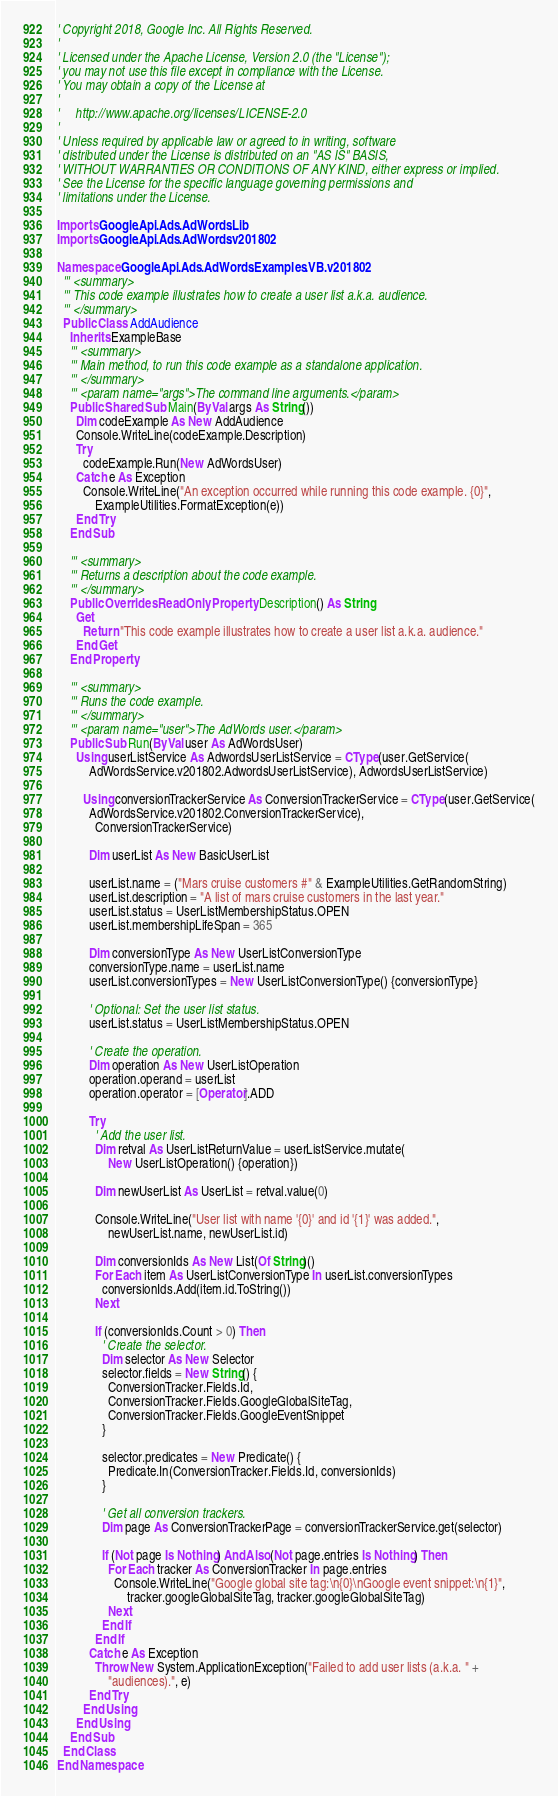Convert code to text. <code><loc_0><loc_0><loc_500><loc_500><_VisualBasic_>' Copyright 2018, Google Inc. All Rights Reserved.
'
' Licensed under the Apache License, Version 2.0 (the "License");
' you may not use this file except in compliance with the License.
' You may obtain a copy of the License at
'
'     http://www.apache.org/licenses/LICENSE-2.0
'
' Unless required by applicable law or agreed to in writing, software
' distributed under the License is distributed on an "AS IS" BASIS,
' WITHOUT WARRANTIES OR CONDITIONS OF ANY KIND, either express or implied.
' See the License for the specific language governing permissions and
' limitations under the License.

Imports Google.Api.Ads.AdWords.Lib
Imports Google.Api.Ads.AdWords.v201802

Namespace Google.Api.Ads.AdWords.Examples.VB.v201802
  ''' <summary>
  ''' This code example illustrates how to create a user list a.k.a. audience.
  ''' </summary>
  Public Class AddAudience
    Inherits ExampleBase
    ''' <summary>
    ''' Main method, to run this code example as a standalone application.
    ''' </summary>
    ''' <param name="args">The command line arguments.</param>
    Public Shared Sub Main(ByVal args As String())
      Dim codeExample As New AddAudience
      Console.WriteLine(codeExample.Description)
      Try
        codeExample.Run(New AdWordsUser)
      Catch e As Exception
        Console.WriteLine("An exception occurred while running this code example. {0}",
            ExampleUtilities.FormatException(e))
      End Try
    End Sub

    ''' <summary>
    ''' Returns a description about the code example.
    ''' </summary>
    Public Overrides ReadOnly Property Description() As String
      Get
        Return "This code example illustrates how to create a user list a.k.a. audience."
      End Get
    End Property

    ''' <summary>
    ''' Runs the code example.
    ''' </summary>
    ''' <param name="user">The AdWords user.</param>
    Public Sub Run(ByVal user As AdWordsUser)
      Using userListService As AdwordsUserListService = CType(user.GetService(
          AdWordsService.v201802.AdwordsUserListService), AdwordsUserListService)

        Using conversionTrackerService As ConversionTrackerService = CType(user.GetService(
          AdWordsService.v201802.ConversionTrackerService),
            ConversionTrackerService)

          Dim userList As New BasicUserList

          userList.name = ("Mars cruise customers #" & ExampleUtilities.GetRandomString)
          userList.description = "A list of mars cruise customers in the last year."
          userList.status = UserListMembershipStatus.OPEN
          userList.membershipLifeSpan = 365

          Dim conversionType As New UserListConversionType
          conversionType.name = userList.name
          userList.conversionTypes = New UserListConversionType() {conversionType}

          ' Optional: Set the user list status.
          userList.status = UserListMembershipStatus.OPEN

          ' Create the operation.
          Dim operation As New UserListOperation
          operation.operand = userList
          operation.operator = [Operator].ADD

          Try
            ' Add the user list.
            Dim retval As UserListReturnValue = userListService.mutate(
                New UserListOperation() {operation})

            Dim newUserList As UserList = retval.value(0)

            Console.WriteLine("User list with name '{0}' and id '{1}' was added.",
                newUserList.name, newUserList.id)

            Dim conversionIds As New List(Of String)()
            For Each item As UserListConversionType In userList.conversionTypes
              conversionIds.Add(item.id.ToString())
            Next

            If (conversionIds.Count > 0) Then
              ' Create the selector.
              Dim selector As New Selector
              selector.fields = New String() {
                ConversionTracker.Fields.Id,
                ConversionTracker.Fields.GoogleGlobalSiteTag,
                ConversionTracker.Fields.GoogleEventSnippet
              }

              selector.predicates = New Predicate() {
                Predicate.In(ConversionTracker.Fields.Id, conversionIds)
              }

              ' Get all conversion trackers.
              Dim page As ConversionTrackerPage = conversionTrackerService.get(selector)

              If (Not page Is Nothing) AndAlso (Not page.entries Is Nothing) Then
                For Each tracker As ConversionTracker In page.entries
                  Console.WriteLine("Google global site tag:\n{0}\nGoogle event snippet:\n{1}",
                      tracker.googleGlobalSiteTag, tracker.googleGlobalSiteTag)
                Next
              End If
            End If
          Catch e As Exception
            Throw New System.ApplicationException("Failed to add user lists (a.k.a. " +
                "audiences).", e)
          End Try
        End Using
      End Using
    End Sub
  End Class
End Namespace
</code> 